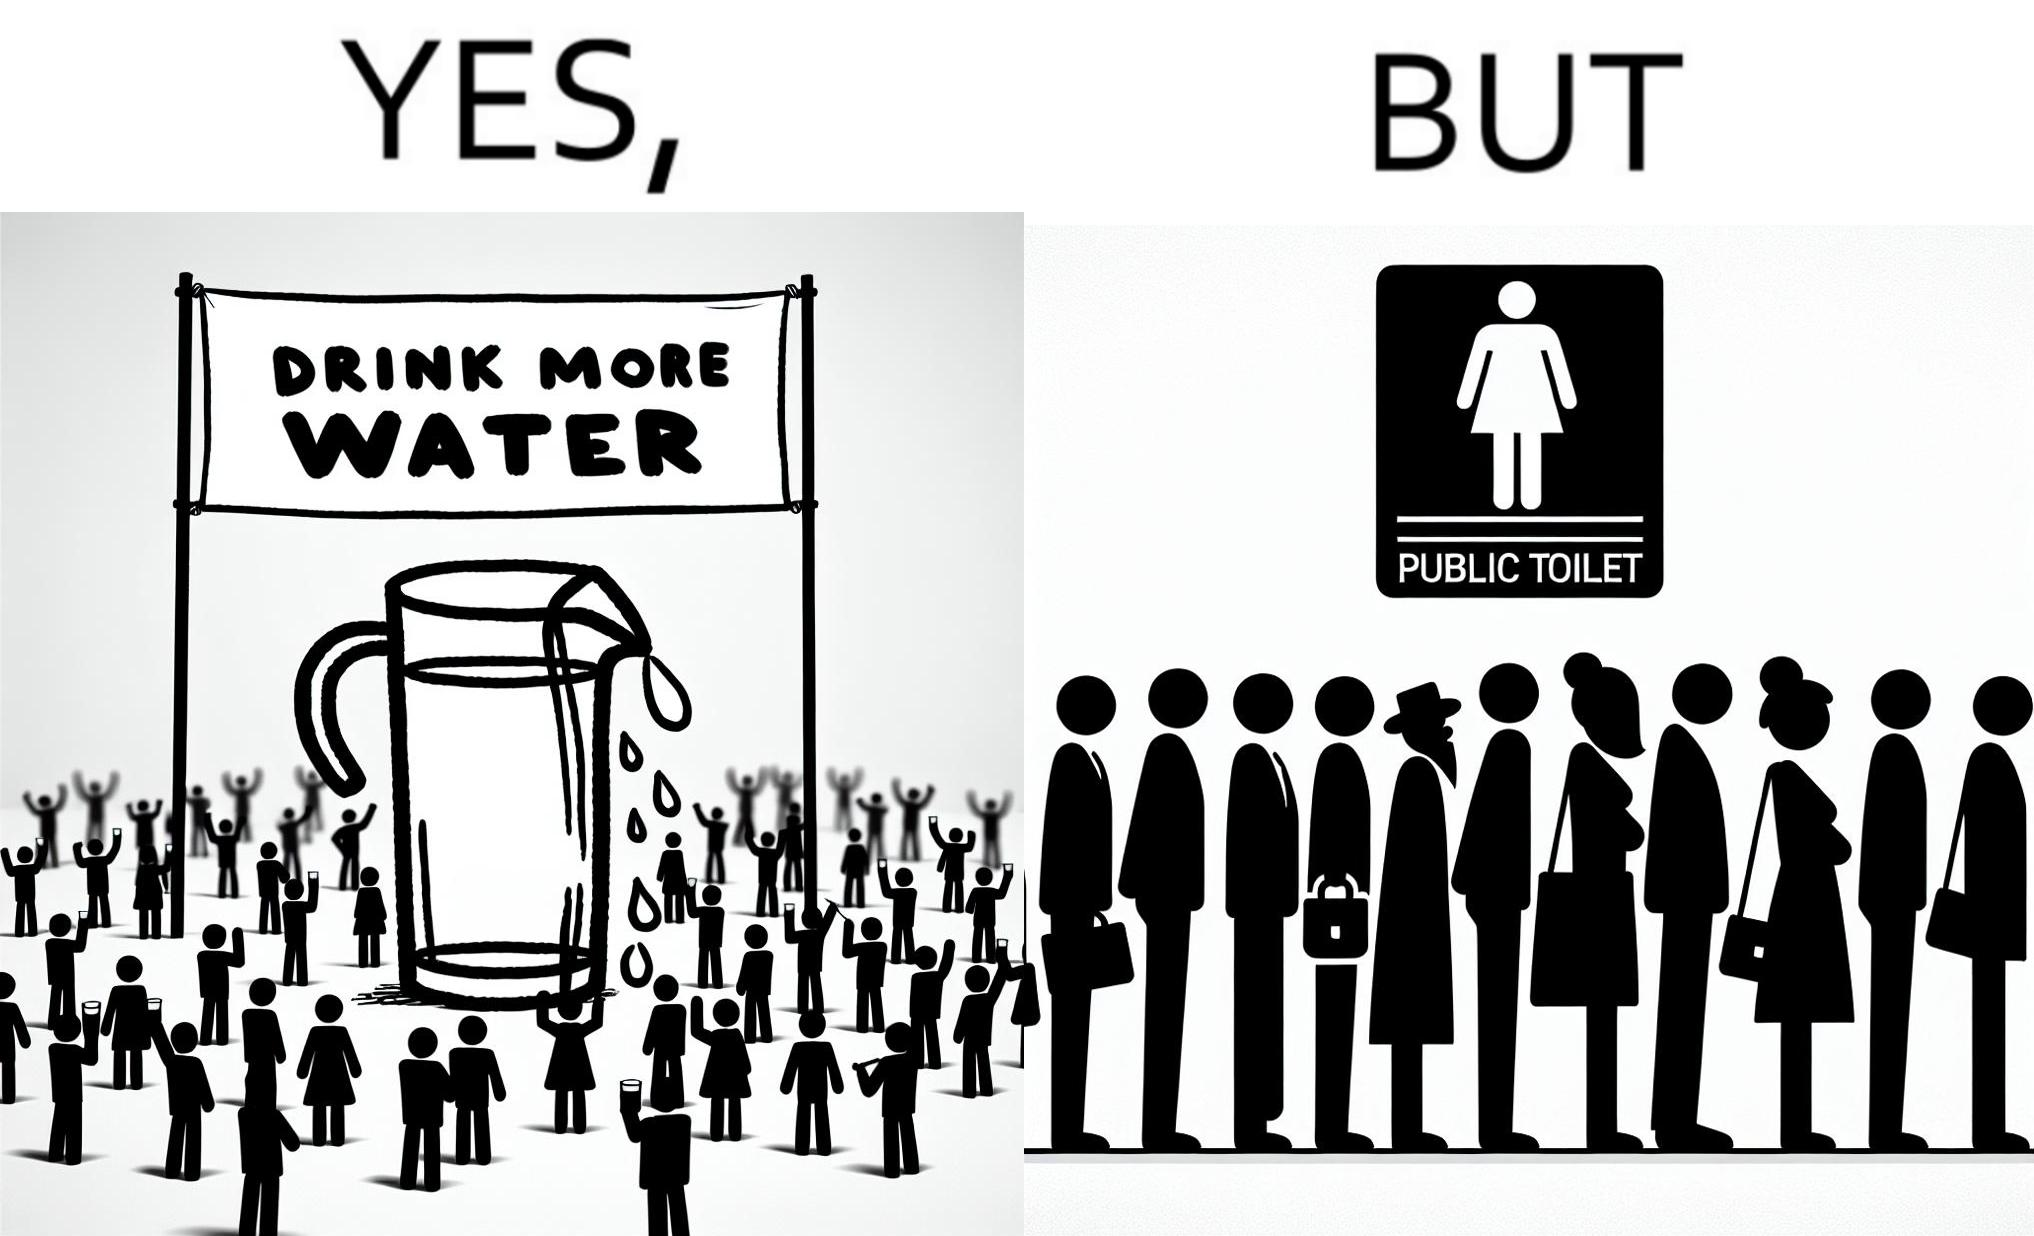Is this image satirical or non-satirical? Yes, this image is satirical. 